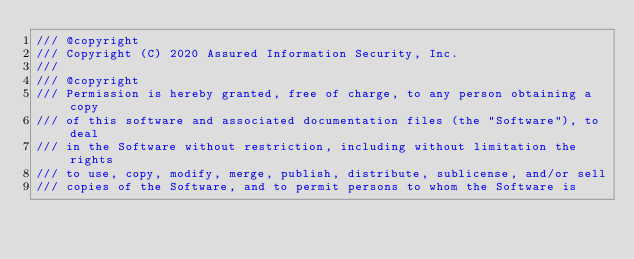Convert code to text. <code><loc_0><loc_0><loc_500><loc_500><_C++_>/// @copyright
/// Copyright (C) 2020 Assured Information Security, Inc.
///
/// @copyright
/// Permission is hereby granted, free of charge, to any person obtaining a copy
/// of this software and associated documentation files (the "Software"), to deal
/// in the Software without restriction, including without limitation the rights
/// to use, copy, modify, merge, publish, distribute, sublicense, and/or sell
/// copies of the Software, and to permit persons to whom the Software is</code> 